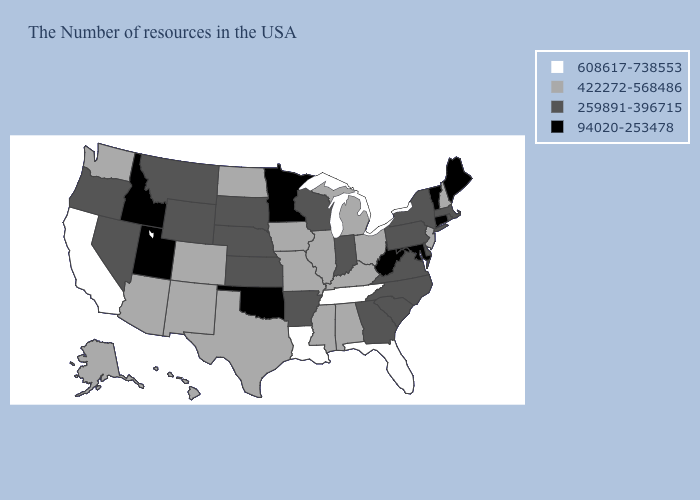Which states hav the highest value in the South?
Be succinct. Florida, Tennessee, Louisiana. What is the highest value in states that border Texas?
Write a very short answer. 608617-738553. What is the value of Maryland?
Quick response, please. 94020-253478. Does Minnesota have the lowest value in the MidWest?
Concise answer only. Yes. Name the states that have a value in the range 422272-568486?
Write a very short answer. New Hampshire, New Jersey, Ohio, Michigan, Kentucky, Alabama, Illinois, Mississippi, Missouri, Iowa, Texas, North Dakota, Colorado, New Mexico, Arizona, Washington, Alaska, Hawaii. Does Maine have the lowest value in the USA?
Quick response, please. Yes. Does Tennessee have the highest value in the USA?
Short answer required. Yes. Name the states that have a value in the range 608617-738553?
Give a very brief answer. Florida, Tennessee, Louisiana, California. Does New Hampshire have the lowest value in the Northeast?
Write a very short answer. No. Among the states that border Oklahoma , which have the highest value?
Be succinct. Missouri, Texas, Colorado, New Mexico. Among the states that border Massachusetts , does New Hampshire have the highest value?
Keep it brief. Yes. Does the map have missing data?
Quick response, please. No. What is the highest value in the MidWest ?
Short answer required. 422272-568486. Among the states that border Massachusetts , does Vermont have the lowest value?
Quick response, please. Yes. What is the lowest value in the West?
Write a very short answer. 94020-253478. 